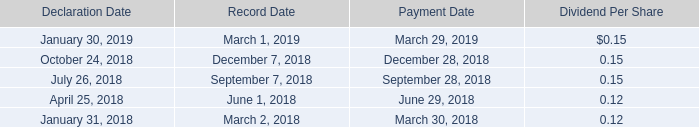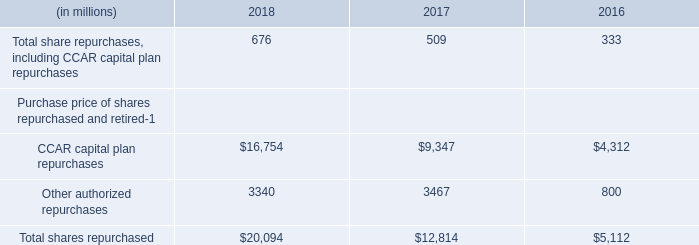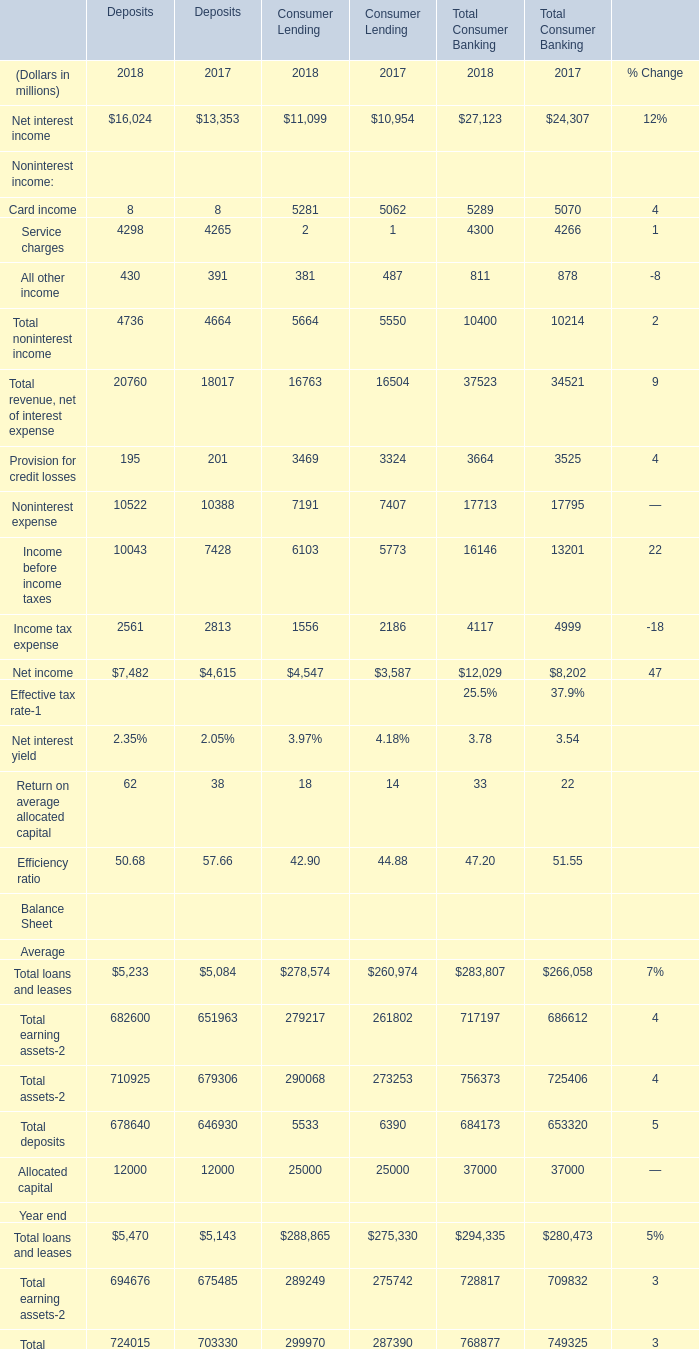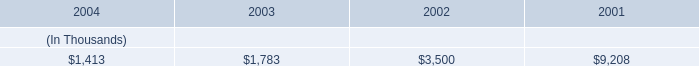What's the difference of Net interest income between 2017 and 2018? (in million) 
Computations: (((16024 + 11099) + 27123) - ((13353 + 10954) + 24307))
Answer: 5632.0. 